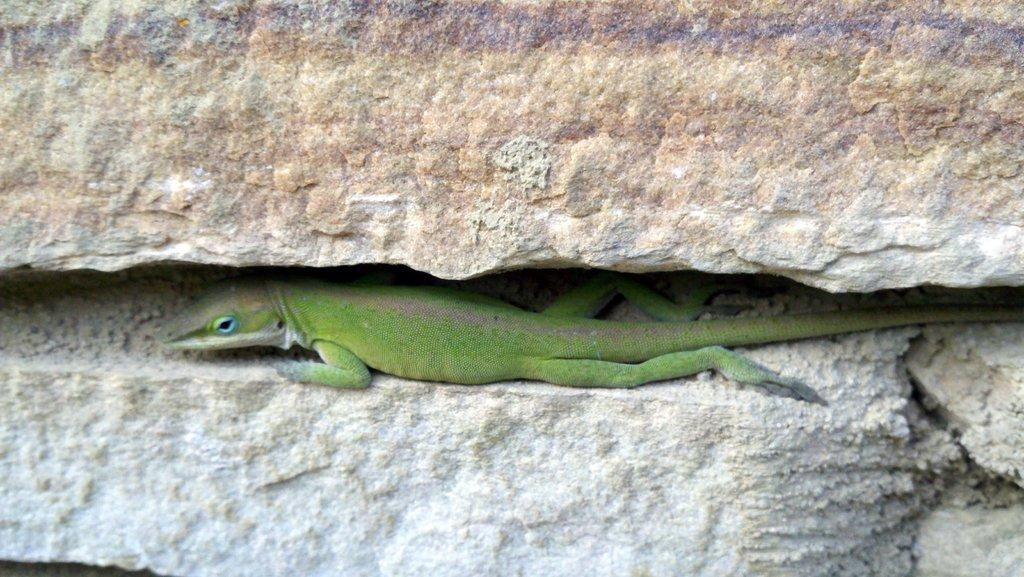What type of animal is in the image? There is a reptile in the image. Where is the reptile located? The reptile is in the middle of a rock. What color is the reptile? The reptile is green in color. What type of crack can be seen in the kettle in the image? There is no kettle present in the image, so it is not possible to determine if there is a crack in it. 